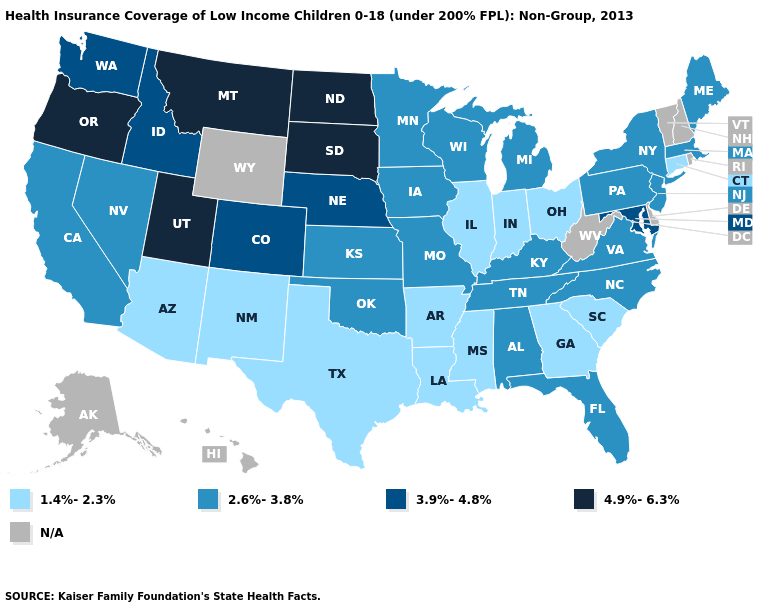Among the states that border Kentucky , which have the lowest value?
Keep it brief. Illinois, Indiana, Ohio. Name the states that have a value in the range 3.9%-4.8%?
Concise answer only. Colorado, Idaho, Maryland, Nebraska, Washington. Among the states that border Delaware , which have the lowest value?
Be succinct. New Jersey, Pennsylvania. Which states hav the highest value in the MidWest?
Short answer required. North Dakota, South Dakota. Does Nevada have the highest value in the West?
Short answer required. No. Which states have the lowest value in the Northeast?
Keep it brief. Connecticut. Name the states that have a value in the range 3.9%-4.8%?
Be succinct. Colorado, Idaho, Maryland, Nebraska, Washington. What is the highest value in the MidWest ?
Concise answer only. 4.9%-6.3%. Name the states that have a value in the range 1.4%-2.3%?
Answer briefly. Arizona, Arkansas, Connecticut, Georgia, Illinois, Indiana, Louisiana, Mississippi, New Mexico, Ohio, South Carolina, Texas. What is the highest value in the West ?
Keep it brief. 4.9%-6.3%. What is the value of Idaho?
Concise answer only. 3.9%-4.8%. Name the states that have a value in the range 4.9%-6.3%?
Write a very short answer. Montana, North Dakota, Oregon, South Dakota, Utah. What is the value of Oregon?
Concise answer only. 4.9%-6.3%. Does the first symbol in the legend represent the smallest category?
Give a very brief answer. Yes. What is the value of Montana?
Give a very brief answer. 4.9%-6.3%. 